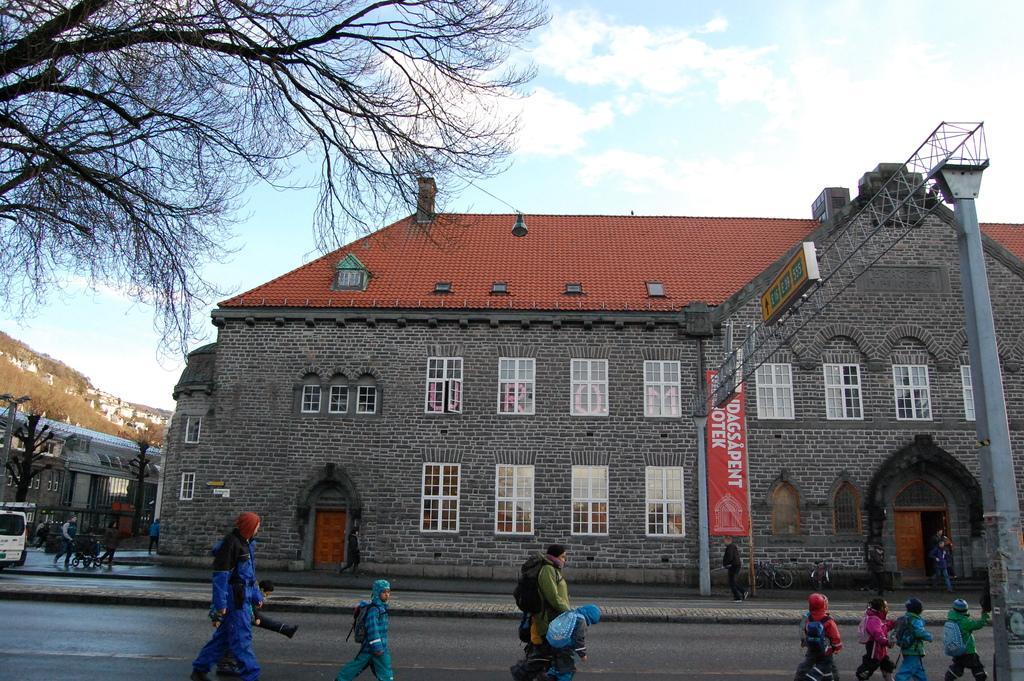Please provide a concise description of this image. In this image few persons and few kids are walking on the road. They are carrying bags. They are wearing jackets. A person's hand holding a baby trolley. Left side there is a vehicle. Few persons are walking beside the road. Few persons are walking on the pavement having metal arch on it. Behind it there is a building. Left side there is a building , behind there is a hill having few trees and houses on it. Left top there is a tree. Top of image there is sky with some clouds. 